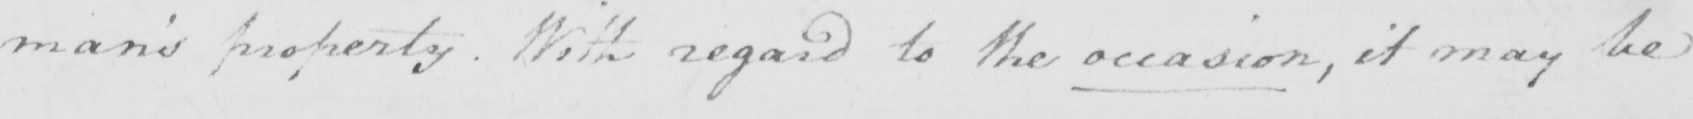What text is written in this handwritten line? man ' s property . With regard to the occasion , it may be 